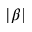Convert formula to latex. <formula><loc_0><loc_0><loc_500><loc_500>| \beta |</formula> 